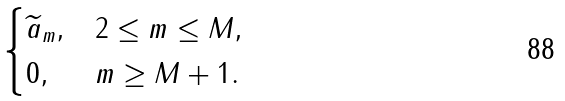<formula> <loc_0><loc_0><loc_500><loc_500>\begin{cases} \widetilde { a } _ { m } , & 2 \leq m \leq M , \\ 0 , & m \geq M + 1 . \end{cases}</formula> 